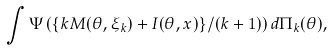<formula> <loc_0><loc_0><loc_500><loc_500>\int \Psi \left ( \{ k M ( \theta , \xi _ { k } ) + I ( \theta , x ) \} / ( k + 1 ) \right ) d \Pi _ { k } ( \theta ) ,</formula> 